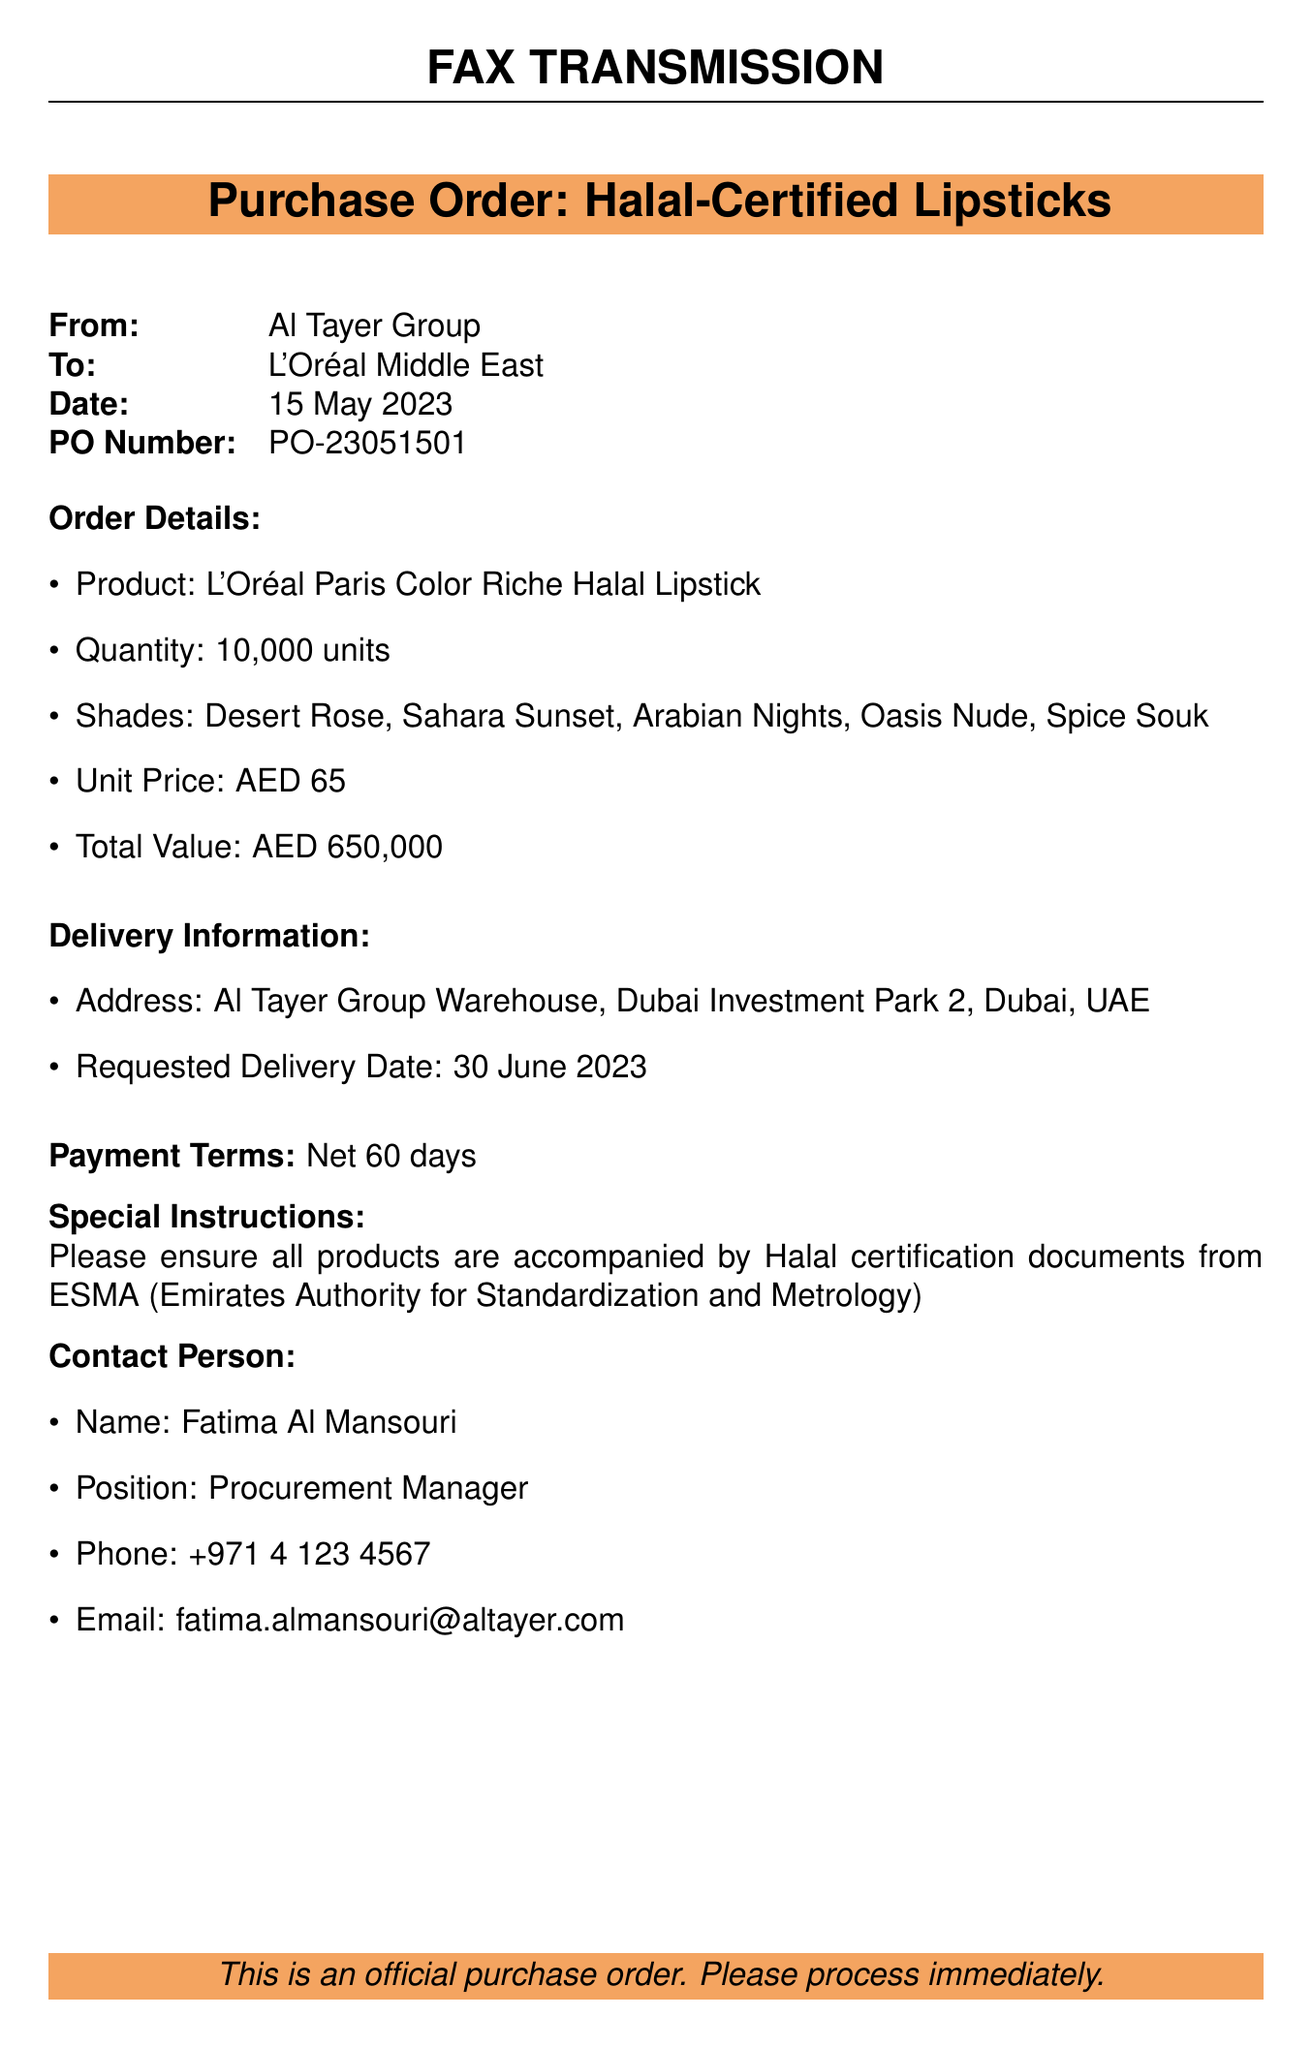What is the product name? The product name is specified in the order details section of the document.
Answer: L'Oréal Paris Color Riche Halal Lipstick What is the quantity ordered? The quantity is indicated in the order details.
Answer: 10,000 units What is the total order value in AED? The total value is provided in the order details.
Answer: AED 650,000 What is the requested delivery date? The delivery date is mentioned under the delivery information.
Answer: 30 June 2023 Who is the contact person for this order? The contact person's name is stated in the contact person section.
Answer: Fatima Al Mansouri What is the payment term for this order? The payment term is listed in the payment terms section.
Answer: Net 60 days How many different shades of lipstick are included in the order? The number of shades is mentioned in the order details.
Answer: Five What is the unit price of each lipstick? The unit price is specified in the order details.
Answer: AED 65 Where should the delivery be sent? The delivery address is provided in the delivery information section.
Answer: Al Tayer Group Warehouse, Dubai Investment Park 2, Dubai, UAE What certification must accompany the products? The required certification is mentioned in the special instructions.
Answer: Halal certification documents from ESMA 